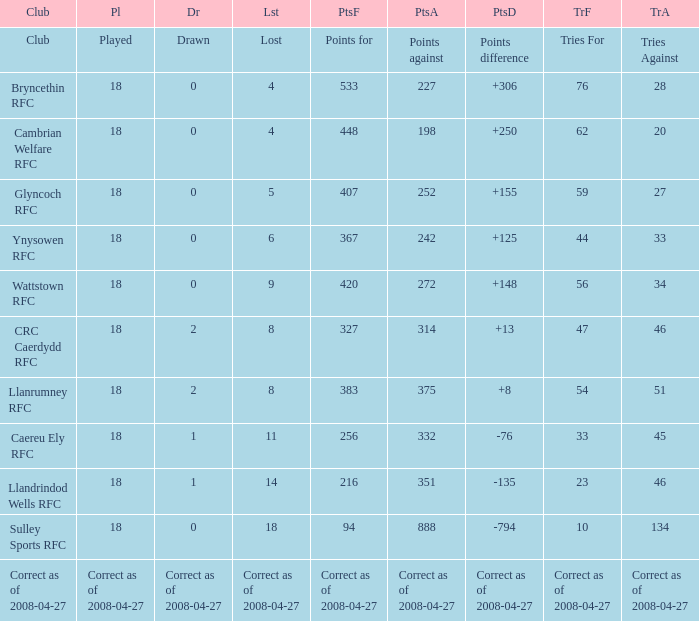What is the value for the item "Lost" when the value "Tries" is 47? 8.0. 